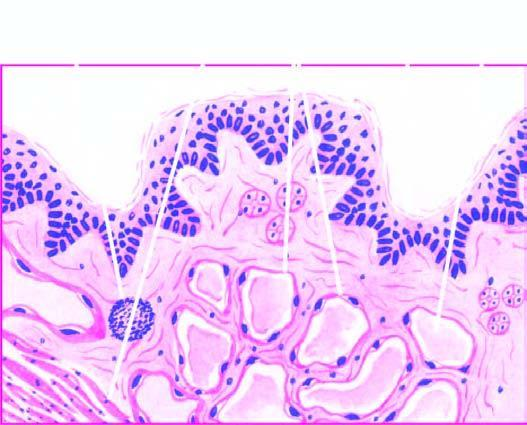does thalassaemia and hbd show scattered collection of lymphocytes?
Answer the question using a single word or phrase. No 